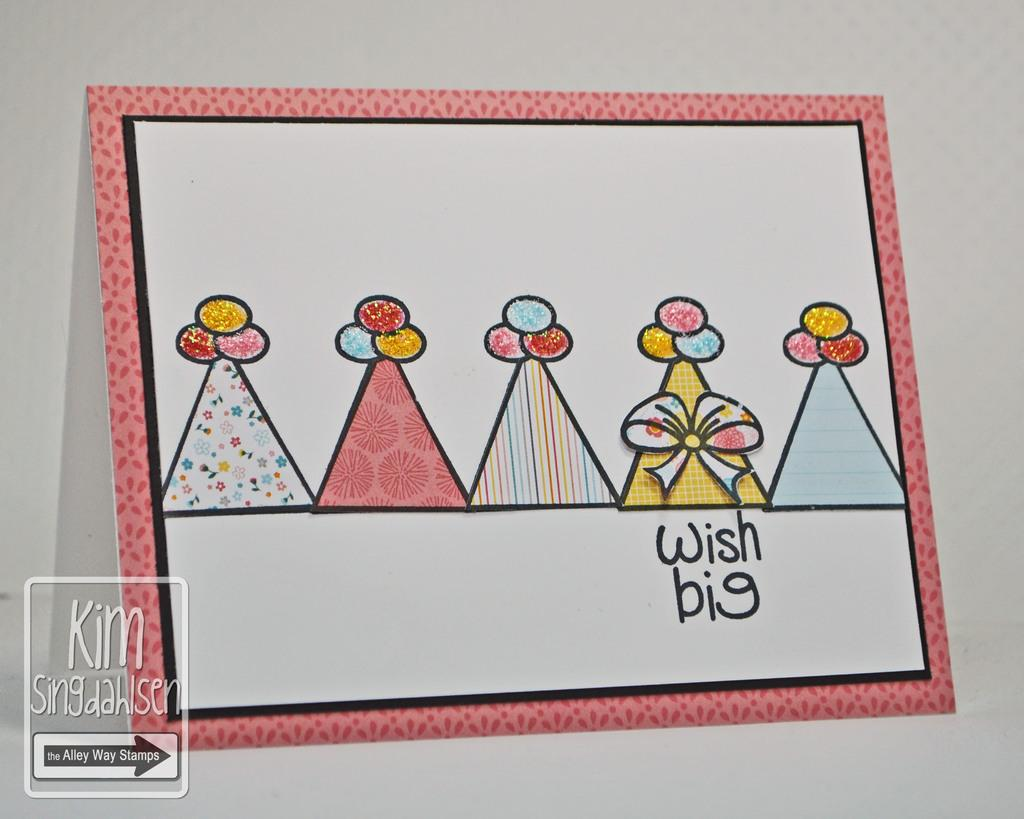<image>
Provide a brief description of the given image. A card that has cute hats on it with Wish Big under the forth 